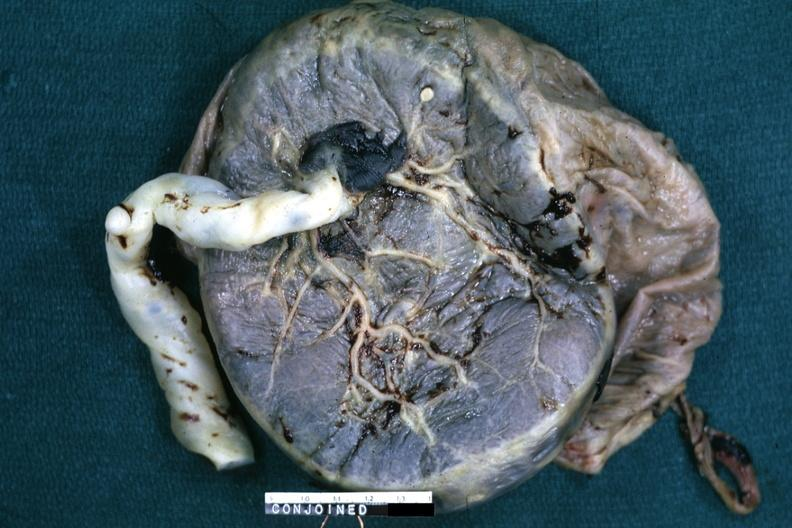s siamese twins present?
Answer the question using a single word or phrase. Yes 